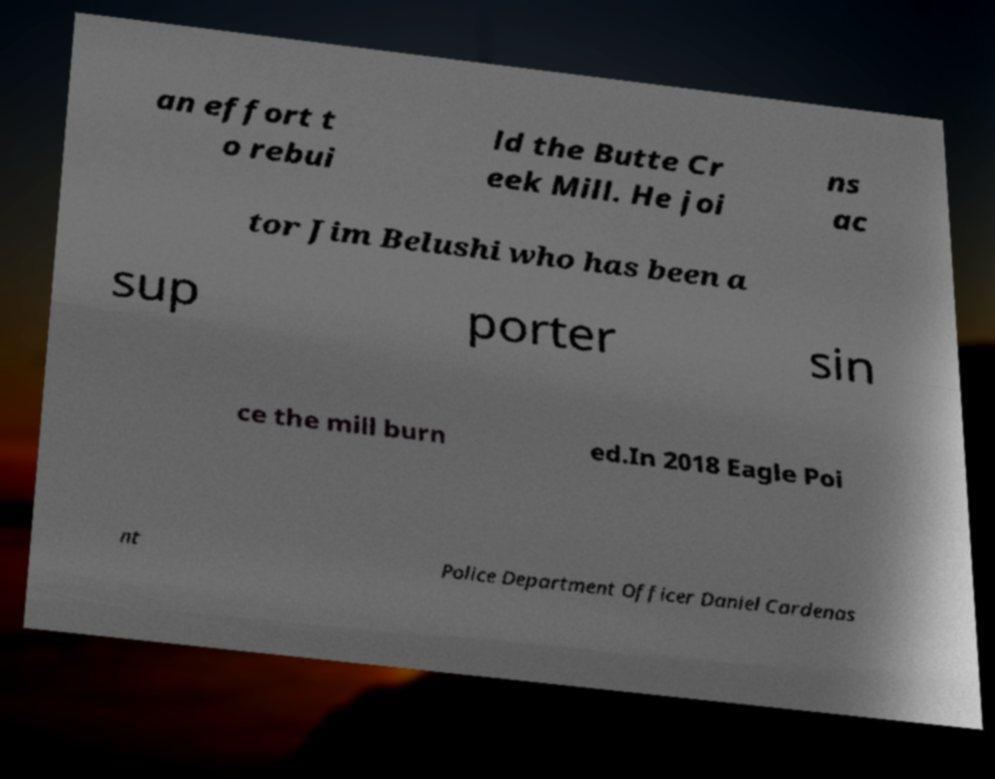Can you read and provide the text displayed in the image?This photo seems to have some interesting text. Can you extract and type it out for me? an effort t o rebui ld the Butte Cr eek Mill. He joi ns ac tor Jim Belushi who has been a sup porter sin ce the mill burn ed.In 2018 Eagle Poi nt Police Department Officer Daniel Cardenas 